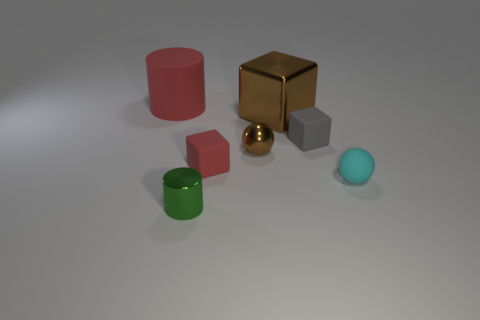What is the material of the block that is the same color as the tiny metal sphere?
Give a very brief answer. Metal. There is a gray thing that is the same size as the rubber sphere; what is it made of?
Make the answer very short. Rubber. Is the number of small blocks greater than the number of big blue shiny objects?
Give a very brief answer. Yes. There is a brown thing behind the rubber cube to the right of the big brown metal object; how big is it?
Keep it short and to the point. Large. The green thing that is the same size as the gray rubber cube is what shape?
Make the answer very short. Cylinder. What is the shape of the shiny thing on the left side of the brown object that is in front of the small matte object behind the tiny red cube?
Give a very brief answer. Cylinder. There is a large object on the left side of the green cylinder; is it the same color as the small matte block in front of the small brown ball?
Offer a terse response. Yes. What number of small red objects are there?
Offer a very short reply. 1. Are there any tiny things on the right side of the small brown metal sphere?
Give a very brief answer. Yes. Are the red object behind the tiny gray matte thing and the red thing that is to the right of the metallic cylinder made of the same material?
Provide a succinct answer. Yes. 